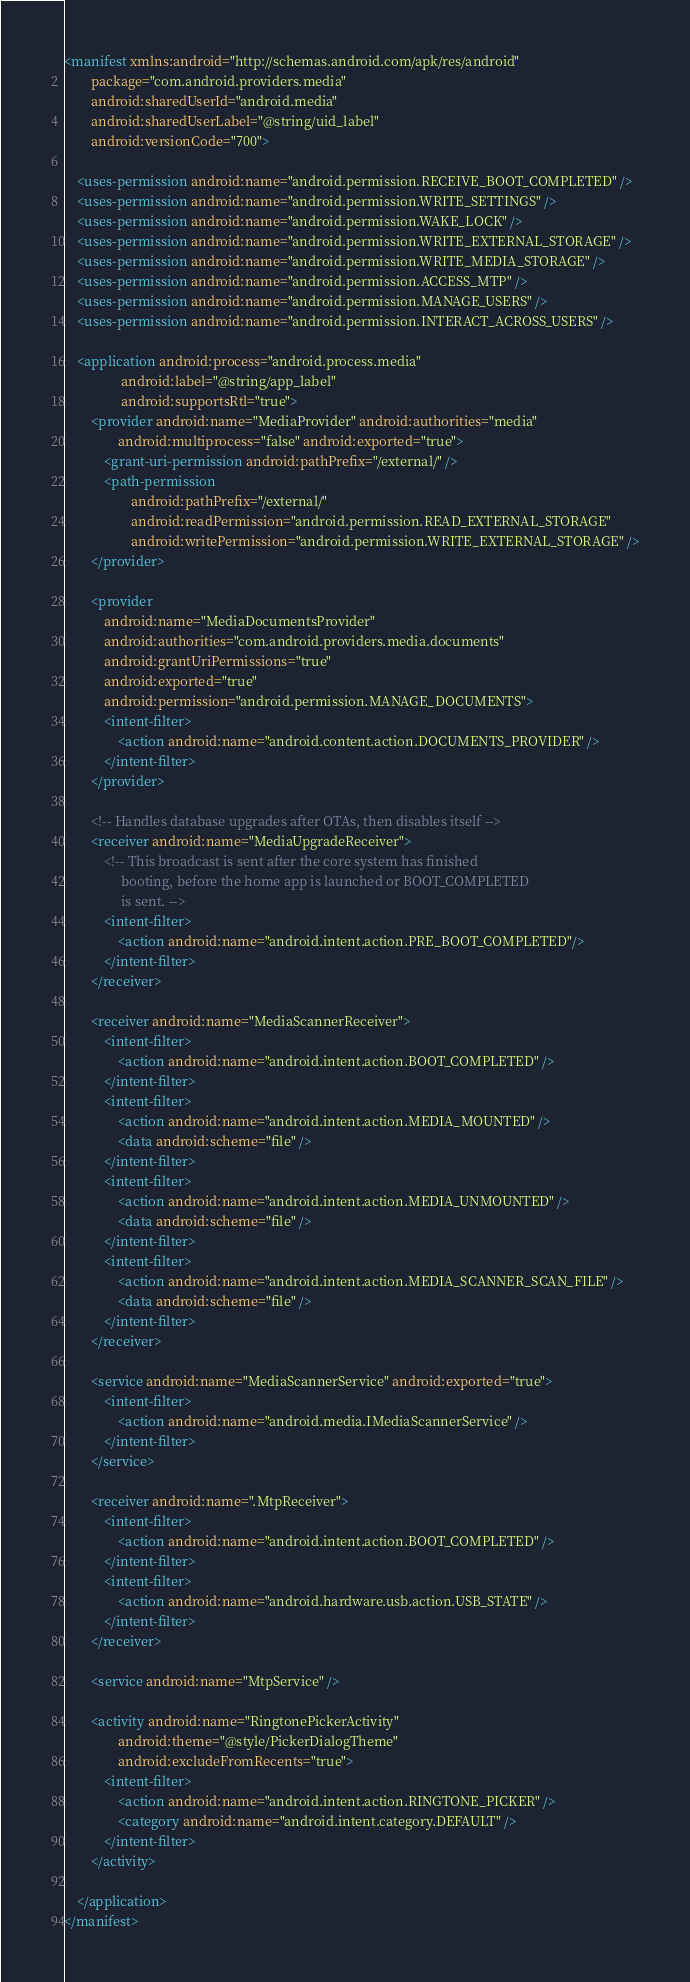Convert code to text. <code><loc_0><loc_0><loc_500><loc_500><_XML_><manifest xmlns:android="http://schemas.android.com/apk/res/android"
        package="com.android.providers.media"
        android:sharedUserId="android.media"
        android:sharedUserLabel="@string/uid_label"
        android:versionCode="700">
        
    <uses-permission android:name="android.permission.RECEIVE_BOOT_COMPLETED" />
    <uses-permission android:name="android.permission.WRITE_SETTINGS" />
    <uses-permission android:name="android.permission.WAKE_LOCK" />
    <uses-permission android:name="android.permission.WRITE_EXTERNAL_STORAGE" />
    <uses-permission android:name="android.permission.WRITE_MEDIA_STORAGE" />
    <uses-permission android:name="android.permission.ACCESS_MTP" />
    <uses-permission android:name="android.permission.MANAGE_USERS" />
    <uses-permission android:name="android.permission.INTERACT_ACROSS_USERS" />

    <application android:process="android.process.media"
                 android:label="@string/app_label"
                 android:supportsRtl="true">
        <provider android:name="MediaProvider" android:authorities="media"
                android:multiprocess="false" android:exported="true">
            <grant-uri-permission android:pathPrefix="/external/" />
            <path-permission
                    android:pathPrefix="/external/"
                    android:readPermission="android.permission.READ_EXTERNAL_STORAGE"
                    android:writePermission="android.permission.WRITE_EXTERNAL_STORAGE" />
        </provider>

        <provider
            android:name="MediaDocumentsProvider"
            android:authorities="com.android.providers.media.documents"
            android:grantUriPermissions="true"
            android:exported="true"
            android:permission="android.permission.MANAGE_DOCUMENTS">
            <intent-filter>
                <action android:name="android.content.action.DOCUMENTS_PROVIDER" />
            </intent-filter>
        </provider>

        <!-- Handles database upgrades after OTAs, then disables itself -->
        <receiver android:name="MediaUpgradeReceiver">
            <!-- This broadcast is sent after the core system has finished
                 booting, before the home app is launched or BOOT_COMPLETED
                 is sent. -->
            <intent-filter>
                <action android:name="android.intent.action.PRE_BOOT_COMPLETED"/>
            </intent-filter>
        </receiver>

        <receiver android:name="MediaScannerReceiver">
            <intent-filter>
                <action android:name="android.intent.action.BOOT_COMPLETED" />
            </intent-filter>
            <intent-filter>
                <action android:name="android.intent.action.MEDIA_MOUNTED" />
                <data android:scheme="file" />
            </intent-filter>
            <intent-filter>
                <action android:name="android.intent.action.MEDIA_UNMOUNTED" />
                <data android:scheme="file" />
            </intent-filter>
            <intent-filter>
                <action android:name="android.intent.action.MEDIA_SCANNER_SCAN_FILE" />
                <data android:scheme="file" />
            </intent-filter>
        </receiver>

        <service android:name="MediaScannerService" android:exported="true">
            <intent-filter>
                <action android:name="android.media.IMediaScannerService" />
            </intent-filter>
        </service>

        <receiver android:name=".MtpReceiver">
            <intent-filter>
                <action android:name="android.intent.action.BOOT_COMPLETED" />
            </intent-filter>
            <intent-filter>
                <action android:name="android.hardware.usb.action.USB_STATE" />
            </intent-filter>
        </receiver>

        <service android:name="MtpService" />

        <activity android:name="RingtonePickerActivity"
                android:theme="@style/PickerDialogTheme"
                android:excludeFromRecents="true">
            <intent-filter>
                <action android:name="android.intent.action.RINGTONE_PICKER" />
                <category android:name="android.intent.category.DEFAULT" />
            </intent-filter>
        </activity>

    </application>
</manifest>
</code> 